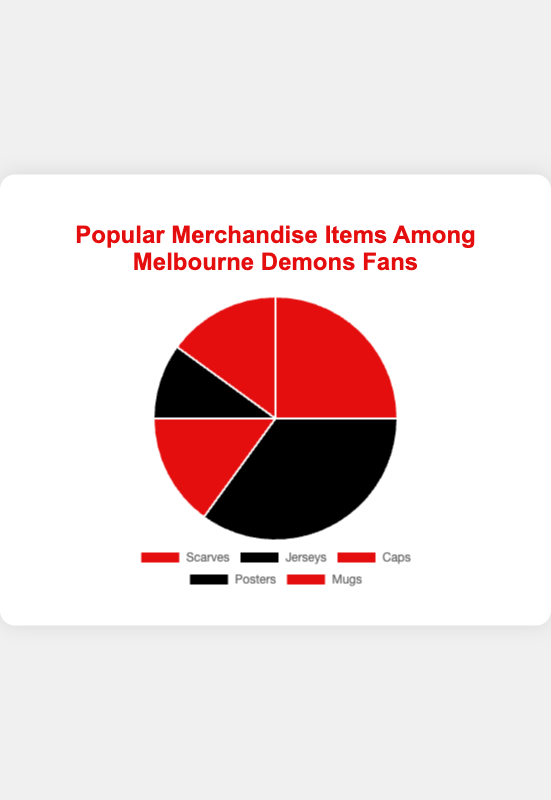What percentage of fans prefer Jerseys over Scarves? The percentage of fans who prefer Jerseys is 35% and the percentage for Scarves is 25%. To find the difference, we subtract the percentage for Scarves from that for Jerseys: 35% - 25% = 10%.
Answer: 10% Which merchandise item is the least popular among Melbourne Demons fans? By looking at the percentage distribution, Posters have the smallest percentage at 10% compared to other items.
Answer: Posters What is the combined percentage of fans who prefer Caps and Mugs? The percentage of fans who prefer Caps is 15% and the percentage for Mugs is also 15%. Adding these together: 15% + 15% = 30%.
Answer: 30% What is the difference in popularity between the most and least popular merchandise items? The most popular item is Jerseys at 35% while the least popular item is Posters at 10%. The difference is 35% - 10% = 25%.
Answer: 25% What merchandise item is the most popular among Melbourne Demons fans? The item with the highest percentage of preference is Jerseys at 35%.
Answer: Jerseys How does the popularity of Scarves compare to the combined popularity of Caps and Mugs? The percentage for Scarves is 25%, and the combined percentage for Caps and Mugs is 15% + 15% = 30%. Scarves are less popular by 5%.
Answer: Scarves are 5% less popular If we combine the percentages of Scarves, Caps, and Mugs, what is the total percentage? The percentages for Scarves, Caps, and Mugs are 25%, 15%, and 15%, respectively. Adding these together: 25% + 15% + 15% = 55%.
Answer: 55% What is the ratio of fans who prefer Jerseys to those who prefer Posters? The percentage of fans for Jerseys is 35% and for Posters is 10%. The ratio is therefore 35:10, which simplifies to 7:2.
Answer: 7:2 